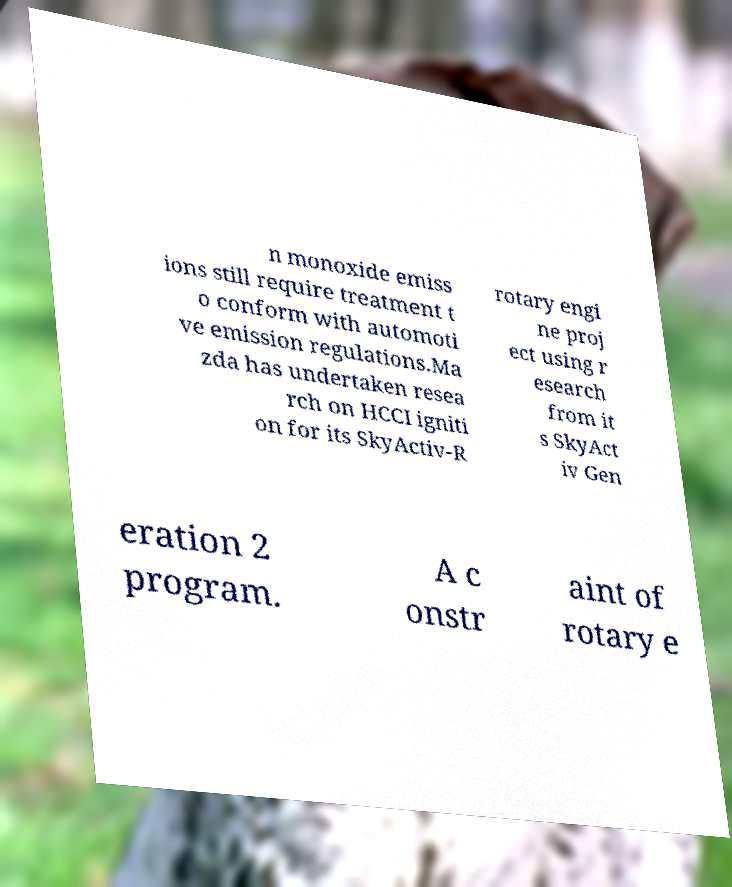Can you accurately transcribe the text from the provided image for me? n monoxide emiss ions still require treatment t o conform with automoti ve emission regulations.Ma zda has undertaken resea rch on HCCI igniti on for its SkyActiv-R rotary engi ne proj ect using r esearch from it s SkyAct iv Gen eration 2 program. A c onstr aint of rotary e 